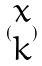Convert formula to latex. <formula><loc_0><loc_0><loc_500><loc_500>( \begin{matrix} x \\ k \end{matrix} )</formula> 